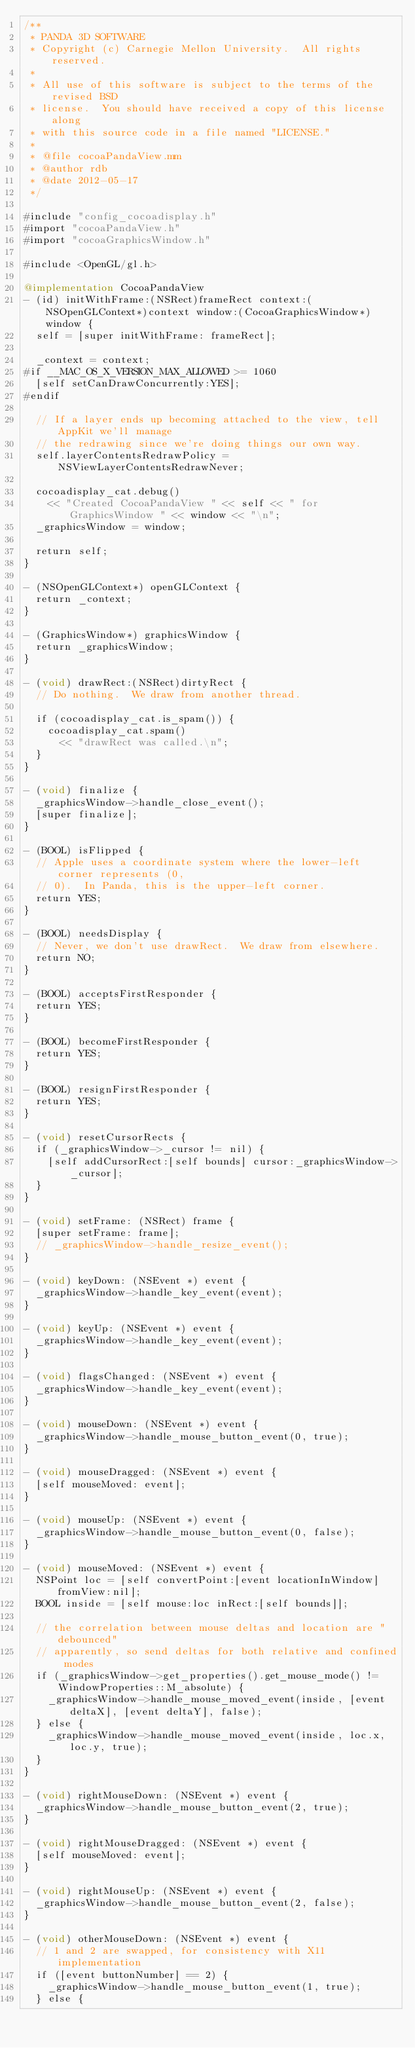<code> <loc_0><loc_0><loc_500><loc_500><_ObjectiveC_>/**
 * PANDA 3D SOFTWARE
 * Copyright (c) Carnegie Mellon University.  All rights reserved.
 *
 * All use of this software is subject to the terms of the revised BSD
 * license.  You should have received a copy of this license along
 * with this source code in a file named "LICENSE."
 *
 * @file cocoaPandaView.mm
 * @author rdb
 * @date 2012-05-17
 */

#include "config_cocoadisplay.h"
#import "cocoaPandaView.h"
#import "cocoaGraphicsWindow.h"

#include <OpenGL/gl.h>

@implementation CocoaPandaView
- (id) initWithFrame:(NSRect)frameRect context:(NSOpenGLContext*)context window:(CocoaGraphicsWindow*)window {
  self = [super initWithFrame: frameRect];

  _context = context;
#if __MAC_OS_X_VERSION_MAX_ALLOWED >= 1060
  [self setCanDrawConcurrently:YES];
#endif

  // If a layer ends up becoming attached to the view, tell AppKit we'll manage
  // the redrawing since we're doing things our own way.
  self.layerContentsRedrawPolicy = NSViewLayerContentsRedrawNever;

  cocoadisplay_cat.debug()
    << "Created CocoaPandaView " << self << " for GraphicsWindow " << window << "\n";
  _graphicsWindow = window;

  return self;
}

- (NSOpenGLContext*) openGLContext {
  return _context;
}

- (GraphicsWindow*) graphicsWindow {
  return _graphicsWindow;
}

- (void) drawRect:(NSRect)dirtyRect {
  // Do nothing.  We draw from another thread.

  if (cocoadisplay_cat.is_spam()) {
    cocoadisplay_cat.spam()
      << "drawRect was called.\n";
  }
}

- (void) finalize {
  _graphicsWindow->handle_close_event();
  [super finalize];
}

- (BOOL) isFlipped {
  // Apple uses a coordinate system where the lower-left corner represents (0,
  // 0).  In Panda, this is the upper-left corner.
  return YES;
}

- (BOOL) needsDisplay {
  // Never, we don't use drawRect.  We draw from elsewhere.
  return NO;
}

- (BOOL) acceptsFirstResponder {
  return YES;
}

- (BOOL) becomeFirstResponder {
  return YES;
}

- (BOOL) resignFirstResponder {
  return YES;
}

- (void) resetCursorRects {
  if (_graphicsWindow->_cursor != nil) {
    [self addCursorRect:[self bounds] cursor:_graphicsWindow->_cursor];
  }
}

- (void) setFrame: (NSRect) frame {
  [super setFrame: frame];
  // _graphicsWindow->handle_resize_event();
}

- (void) keyDown: (NSEvent *) event {
  _graphicsWindow->handle_key_event(event);
}

- (void) keyUp: (NSEvent *) event {
  _graphicsWindow->handle_key_event(event);
}

- (void) flagsChanged: (NSEvent *) event {
  _graphicsWindow->handle_key_event(event);
}

- (void) mouseDown: (NSEvent *) event {
  _graphicsWindow->handle_mouse_button_event(0, true);
}

- (void) mouseDragged: (NSEvent *) event {
  [self mouseMoved: event];
}

- (void) mouseUp: (NSEvent *) event {
  _graphicsWindow->handle_mouse_button_event(0, false);
}

- (void) mouseMoved: (NSEvent *) event {
  NSPoint loc = [self convertPoint:[event locationInWindow] fromView:nil];
  BOOL inside = [self mouse:loc inRect:[self bounds]];

  // the correlation between mouse deltas and location are "debounced"
  // apparently, so send deltas for both relative and confined modes
  if (_graphicsWindow->get_properties().get_mouse_mode() != WindowProperties::M_absolute) {
    _graphicsWindow->handle_mouse_moved_event(inside, [event deltaX], [event deltaY], false);
  } else {
    _graphicsWindow->handle_mouse_moved_event(inside, loc.x, loc.y, true);
  }
}

- (void) rightMouseDown: (NSEvent *) event {
  _graphicsWindow->handle_mouse_button_event(2, true);
}

- (void) rightMouseDragged: (NSEvent *) event {
  [self mouseMoved: event];
}

- (void) rightMouseUp: (NSEvent *) event {
  _graphicsWindow->handle_mouse_button_event(2, false);
}

- (void) otherMouseDown: (NSEvent *) event {
  // 1 and 2 are swapped, for consistency with X11 implementation
  if ([event buttonNumber] == 2) {
    _graphicsWindow->handle_mouse_button_event(1, true);
  } else {</code> 